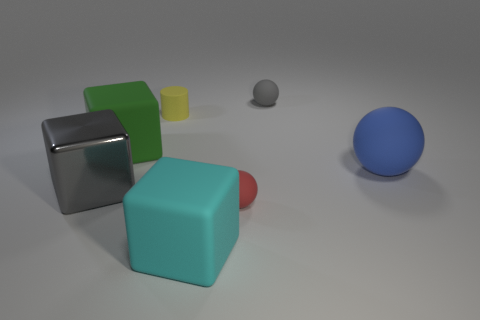Is there a cyan cube that has the same material as the big green object?
Offer a very short reply. Yes. There is a block in front of the metal cube; what color is it?
Provide a succinct answer. Cyan. Is the number of cyan blocks that are behind the cylinder the same as the number of small rubber objects that are right of the cyan rubber cube?
Give a very brief answer. No. What material is the gray thing that is left of the big rubber cube that is to the right of the green matte thing?
Ensure brevity in your answer.  Metal. What number of things are either large blue objects or things that are to the left of the cyan matte block?
Provide a succinct answer. 4. The green cube that is the same material as the tiny gray sphere is what size?
Give a very brief answer. Large. Is the number of big rubber balls that are in front of the yellow rubber cylinder greater than the number of purple metallic cubes?
Your answer should be compact. Yes. There is a block that is right of the large gray cube and on the left side of the tiny yellow rubber thing; how big is it?
Your answer should be compact. Large. There is a big green thing that is the same shape as the big cyan matte object; what material is it?
Your answer should be compact. Rubber. Do the matte thing behind the yellow object and the large metallic cube have the same size?
Provide a succinct answer. No. 